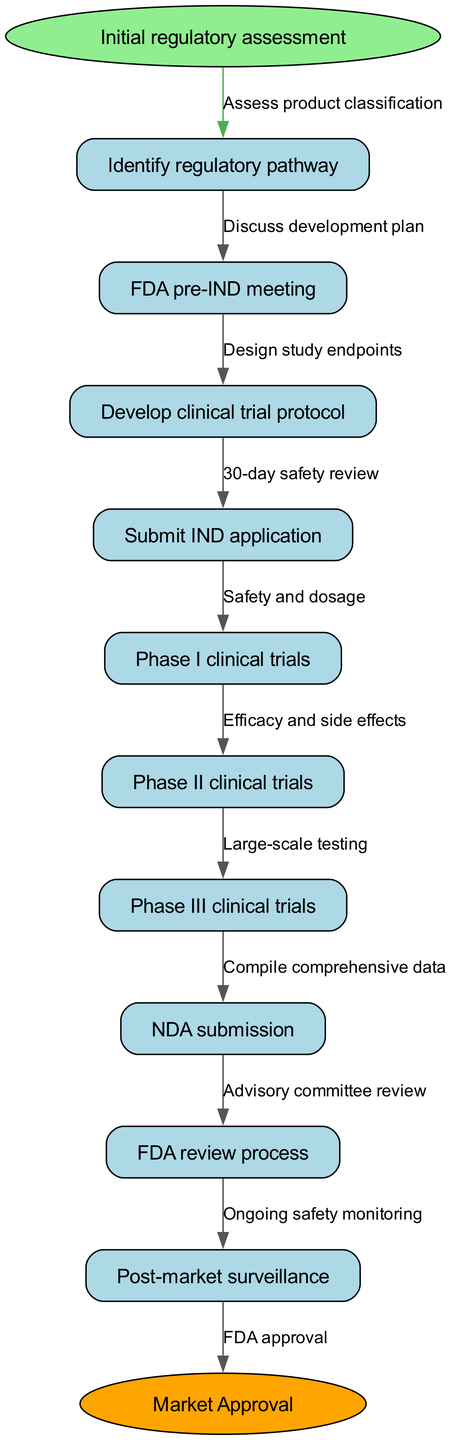What is the starting point of the clinical pathway? The starting point of the clinical pathway is explicitly labeled in the diagram as "Initial regulatory assessment." It leads to the first node in the sequence.
Answer: Initial regulatory assessment How many nodes are there in the clinical pathway? By counting the nodes listed in the diagram, including both the start and endpoint nodes, there are a total of 11 nodes described in the pathway: the start, 9 clinical pathways, and the endpoint.
Answer: 11 What is the last step before market approval? The last step before reaching "Market Approval" is "FDA review process," which is connected directly to the endpoint node.
Answer: FDA review process Which phase comes after Phase I clinical trials? By following the progression of nodes in the diagram, the node that comes directly after "Phase I clinical trials" is "Phase II clinical trials."
Answer: Phase II clinical trials What edge connects the "Submit IND application" node to the next node? The edge that connects "Submit IND application" to the next node is labeled "30-day safety review." This shows the direct relationship and flow from submission to safety review.
Answer: 30-day safety review What are the endpoints of the clinical pathway? The endpoints of the clinical pathway are "Market Approval." This is where the pathway concludes after all nodes have been processed.
Answer: Market Approval In which node is the discussion of the development plan held? The discussion regarding the development plan occurs during the "FDA pre-IND meeting" node, as indicated in the pathway's logical flow.
Answer: FDA pre-IND meeting What type of tests occurs in Phase III? In Phase III clinical trials, "Large-scale testing" is conducted, as described in the pathway. This indicates the nature of the tests performed during this phase.
Answer: Large-scale testing What node follows the "NDA submission"? By examining the directed edges in the diagram, the node that follows "NDA submission" is "FDA review process." This signifies the next step in the regulatory review cycle.
Answer: FDA review process 